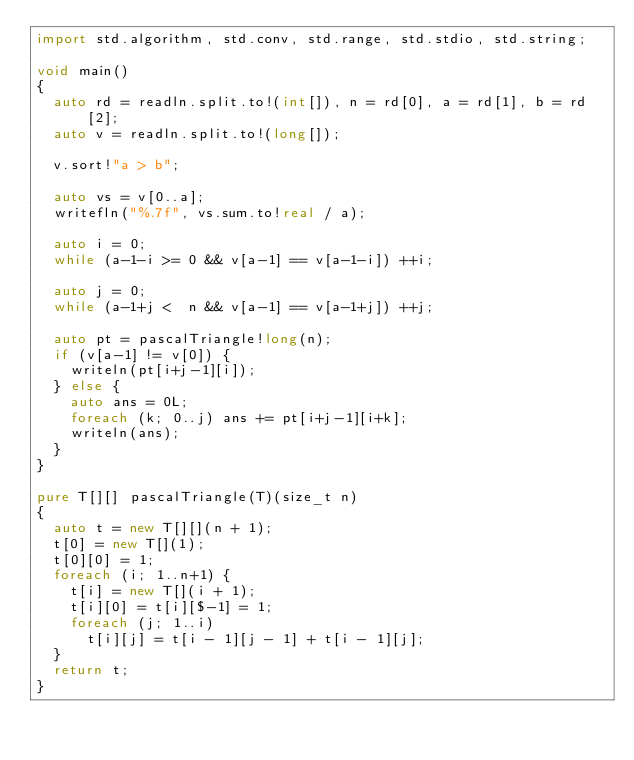<code> <loc_0><loc_0><loc_500><loc_500><_D_>import std.algorithm, std.conv, std.range, std.stdio, std.string;

void main()
{
  auto rd = readln.split.to!(int[]), n = rd[0], a = rd[1], b = rd[2];
  auto v = readln.split.to!(long[]);

  v.sort!"a > b";

  auto vs = v[0..a];
  writefln("%.7f", vs.sum.to!real / a);

  auto i = 0;
  while (a-1-i >= 0 && v[a-1] == v[a-1-i]) ++i;

  auto j = 0;
  while (a-1+j <  n && v[a-1] == v[a-1+j]) ++j;

  auto pt = pascalTriangle!long(n);
  if (v[a-1] != v[0]) {
    writeln(pt[i+j-1][i]);
  } else {
    auto ans = 0L;
    foreach (k; 0..j) ans += pt[i+j-1][i+k];
    writeln(ans);
  }
}

pure T[][] pascalTriangle(T)(size_t n)
{
  auto t = new T[][](n + 1);
  t[0] = new T[](1);
  t[0][0] = 1;
  foreach (i; 1..n+1) {
    t[i] = new T[](i + 1);
    t[i][0] = t[i][$-1] = 1;
    foreach (j; 1..i)
      t[i][j] = t[i - 1][j - 1] + t[i - 1][j];
  }
  return t;
}
</code> 